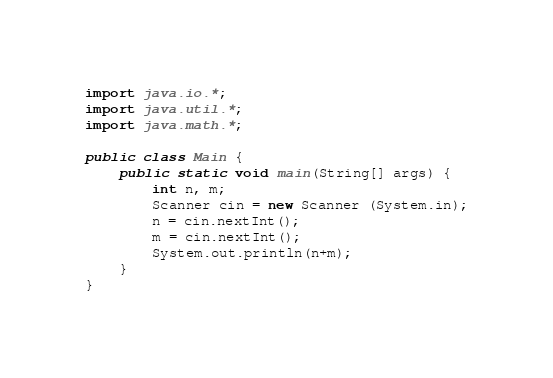<code> <loc_0><loc_0><loc_500><loc_500><_Java_>import java.io.*;
import java.util.*;
import java.math.*;

public class Main {
    public static void main(String[] args) {
        int n, m;
        Scanner cin = new Scanner (System.in);
        n = cin.nextInt();
        m = cin.nextInt();
		System.out.println(n+m);
    }
}</code> 